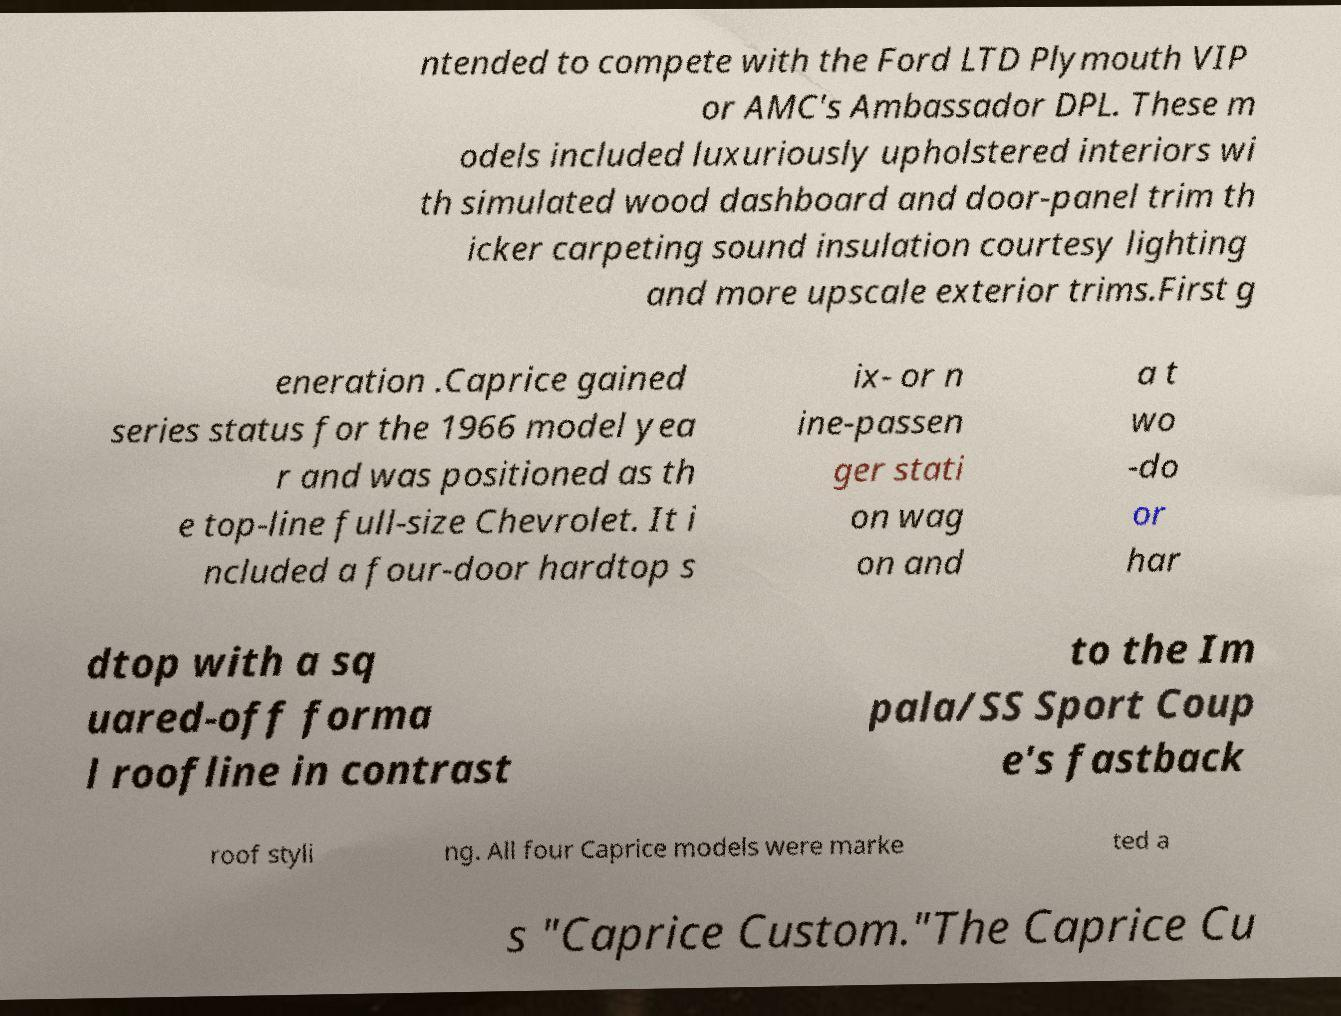I need the written content from this picture converted into text. Can you do that? ntended to compete with the Ford LTD Plymouth VIP or AMC's Ambassador DPL. These m odels included luxuriously upholstered interiors wi th simulated wood dashboard and door-panel trim th icker carpeting sound insulation courtesy lighting and more upscale exterior trims.First g eneration .Caprice gained series status for the 1966 model yea r and was positioned as th e top-line full-size Chevrolet. It i ncluded a four-door hardtop s ix- or n ine-passen ger stati on wag on and a t wo -do or har dtop with a sq uared-off forma l roofline in contrast to the Im pala/SS Sport Coup e's fastback roof styli ng. All four Caprice models were marke ted a s "Caprice Custom."The Caprice Cu 